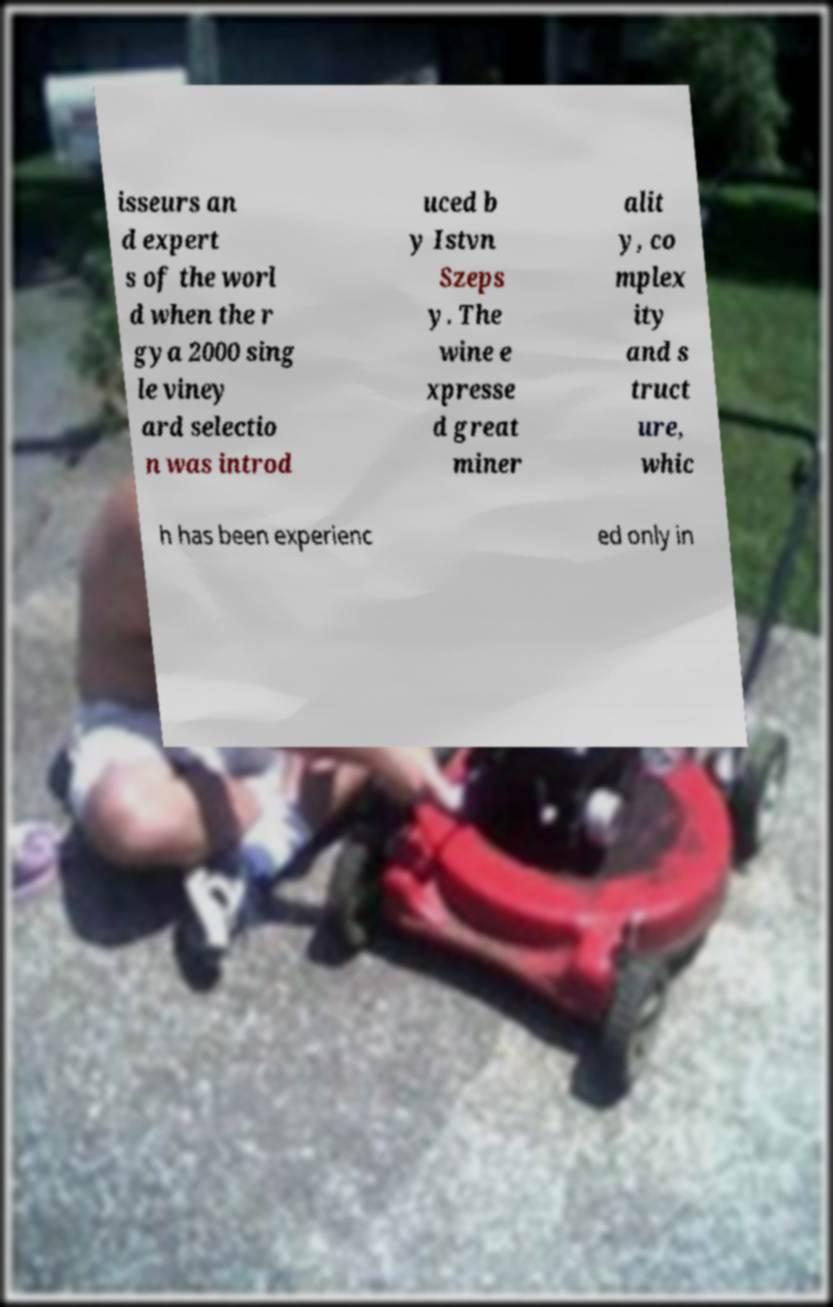There's text embedded in this image that I need extracted. Can you transcribe it verbatim? isseurs an d expert s of the worl d when the r gya 2000 sing le viney ard selectio n was introd uced b y Istvn Szeps y. The wine e xpresse d great miner alit y, co mplex ity and s truct ure, whic h has been experienc ed only in 